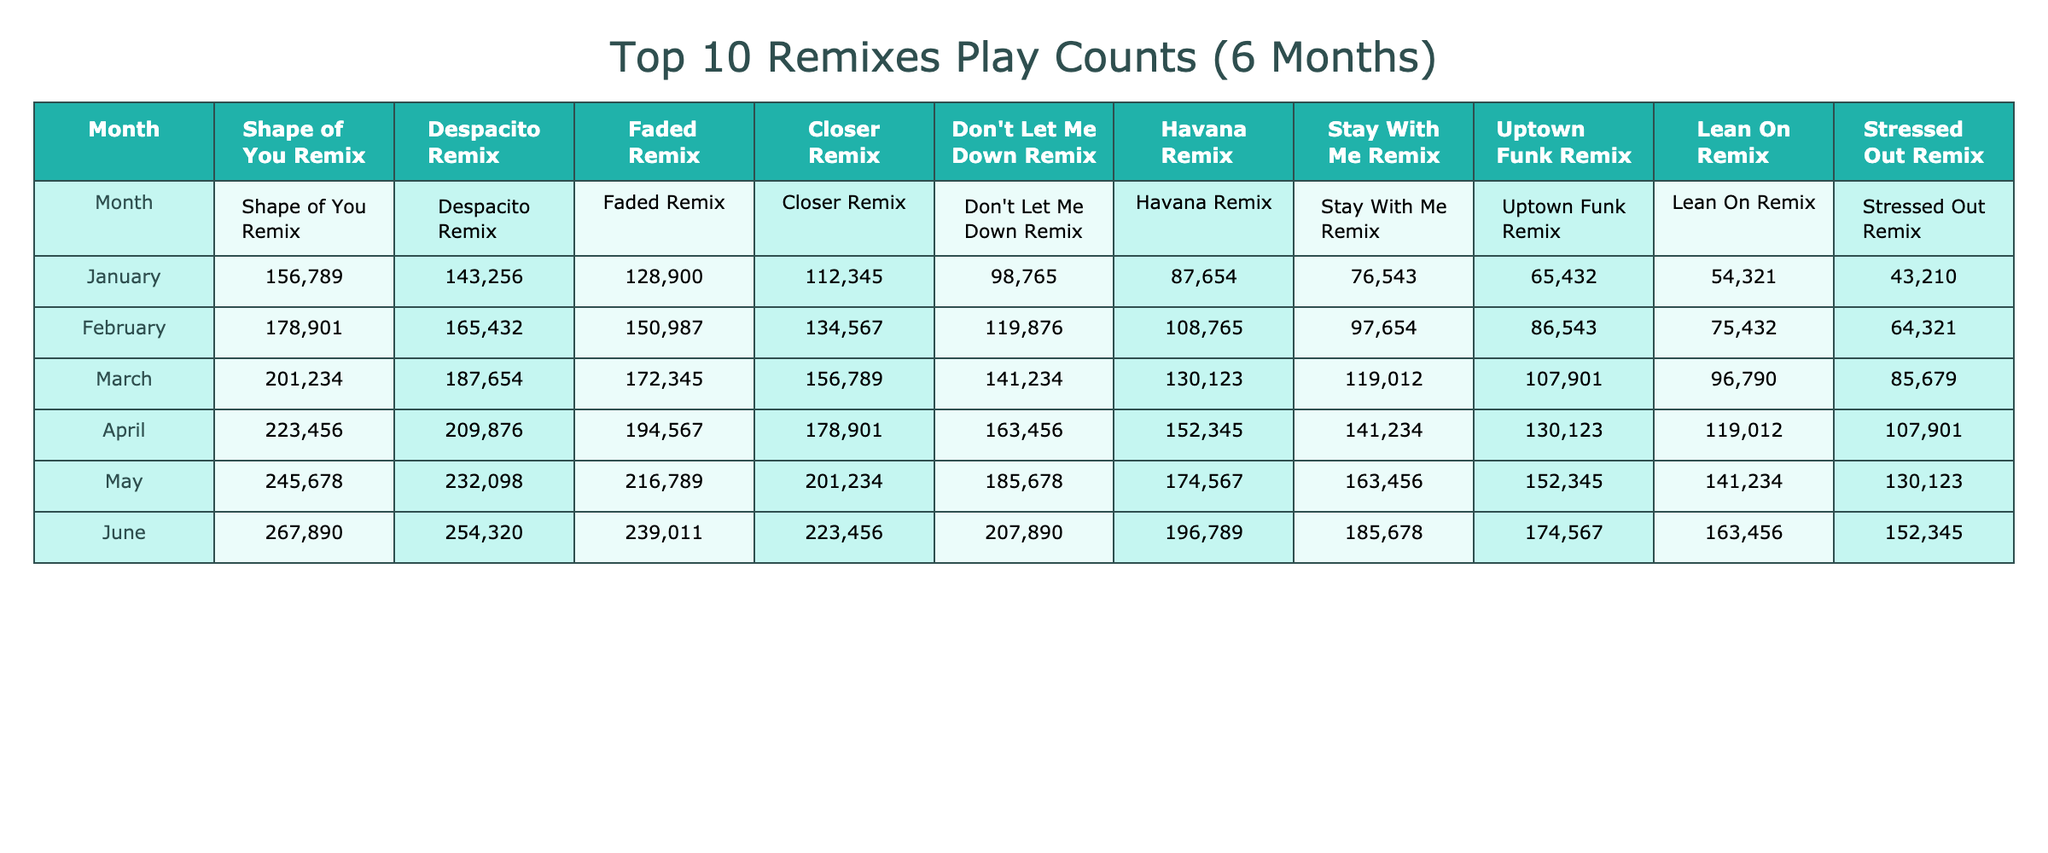What was the highest play count for the 'Shape of You Remix'? The highest play count for 'Shape of You Remix' is found in June, where the value is 267,890.
Answer: 267,890 Which remix had the lowest play count in January? Looking at the play counts for January, 'Stressed Out Remix' has the lowest play count at 43,210.
Answer: 43,210 What is the total play count for all remixes in March? To find the total play count in March, sum the values for that month: 172,345 + 156,789 + 141,234 + 130,123 + 119,012 + 107,901 + 96,790 + 85,679 = 1,232,076.
Answer: 1,232,076 Which remix had the largest increase in play count from January to June? Calculate the difference between June and January for each remix: 'Shape of You Remix' (267,890 - 156,789), 'Despacito Remix' (254,320 - 143,256), and so on. The largest increase is 'Shape of You Remix' with 111,101.
Answer: 'Shape of You Remix' Was the play count for 'Closer Remix' higher in May than in April? In May, 'Closer Remix' reached 201,234 while in April it had 178,901. Since 201,234 is greater than 178,901, the play count in May was indeed higher.
Answer: Yes What is the average play count for 'Havana Remix' over the 6-month period? Add the play counts for 'Havana Remix' for all months (87,654 + 108,765 + 130,123 + 152,345 + 174,567 + 196,789 = 860,243), then divide by the number of months (6): 860,243 / 6 = 143,373.83.
Answer: 143,373.83 Which remix consistently had the highest play count across all months? After examining all months, 'Shape of You Remix' had the highest count in each month, making it the most consistently high.
Answer: 'Shape of You Remix' What percentage of the total plays in June does 'Stressed Out Remix' account for? In June, the total plays were 1,399,158 (sum all remix values). 'Stressed Out Remix' played 185,678 times. The percentage is (185,678 / 1,399,158) * 100 = approximately 13.29%.
Answer: 13.29% 